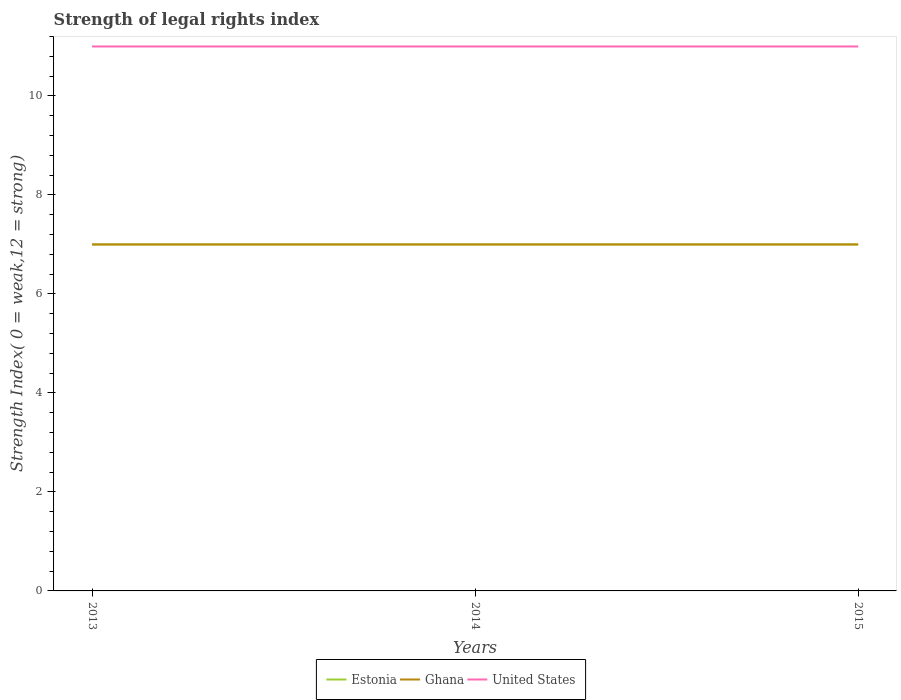How many different coloured lines are there?
Offer a terse response. 3. Does the line corresponding to Estonia intersect with the line corresponding to Ghana?
Provide a short and direct response. Yes. Across all years, what is the maximum strength index in United States?
Offer a very short reply. 11. In which year was the strength index in Estonia maximum?
Keep it short and to the point. 2013. What is the total strength index in Estonia in the graph?
Provide a short and direct response. 0. What is the difference between the highest and the second highest strength index in Estonia?
Your response must be concise. 0. Is the strength index in Ghana strictly greater than the strength index in United States over the years?
Your answer should be very brief. Yes. How many lines are there?
Give a very brief answer. 3. What is the difference between two consecutive major ticks on the Y-axis?
Your answer should be compact. 2. Are the values on the major ticks of Y-axis written in scientific E-notation?
Make the answer very short. No. Does the graph contain grids?
Make the answer very short. No. Where does the legend appear in the graph?
Provide a short and direct response. Bottom center. How are the legend labels stacked?
Provide a succinct answer. Horizontal. What is the title of the graph?
Keep it short and to the point. Strength of legal rights index. Does "Korea (Republic)" appear as one of the legend labels in the graph?
Your answer should be very brief. No. What is the label or title of the Y-axis?
Your answer should be very brief. Strength Index( 0 = weak,12 = strong). What is the Strength Index( 0 = weak,12 = strong) of Estonia in 2014?
Your answer should be compact. 7. What is the Strength Index( 0 = weak,12 = strong) of United States in 2014?
Make the answer very short. 11. What is the Strength Index( 0 = weak,12 = strong) in Estonia in 2015?
Offer a terse response. 7. Across all years, what is the maximum Strength Index( 0 = weak,12 = strong) of Ghana?
Keep it short and to the point. 7. Across all years, what is the maximum Strength Index( 0 = weak,12 = strong) of United States?
Give a very brief answer. 11. What is the total Strength Index( 0 = weak,12 = strong) of Estonia in the graph?
Provide a short and direct response. 21. What is the total Strength Index( 0 = weak,12 = strong) in Ghana in the graph?
Your response must be concise. 21. What is the total Strength Index( 0 = weak,12 = strong) of United States in the graph?
Make the answer very short. 33. What is the difference between the Strength Index( 0 = weak,12 = strong) of Estonia in 2013 and that in 2014?
Offer a very short reply. 0. What is the difference between the Strength Index( 0 = weak,12 = strong) in Ghana in 2013 and that in 2014?
Give a very brief answer. 0. What is the difference between the Strength Index( 0 = weak,12 = strong) in Estonia in 2013 and that in 2015?
Provide a succinct answer. 0. What is the difference between the Strength Index( 0 = weak,12 = strong) in Ghana in 2014 and that in 2015?
Give a very brief answer. 0. What is the difference between the Strength Index( 0 = weak,12 = strong) of United States in 2014 and that in 2015?
Ensure brevity in your answer.  0. What is the difference between the Strength Index( 0 = weak,12 = strong) of Ghana in 2013 and the Strength Index( 0 = weak,12 = strong) of United States in 2014?
Make the answer very short. -4. What is the difference between the Strength Index( 0 = weak,12 = strong) in Estonia in 2013 and the Strength Index( 0 = weak,12 = strong) in United States in 2015?
Make the answer very short. -4. What is the difference between the Strength Index( 0 = weak,12 = strong) in Estonia in 2014 and the Strength Index( 0 = weak,12 = strong) in Ghana in 2015?
Keep it short and to the point. 0. What is the difference between the Strength Index( 0 = weak,12 = strong) in Estonia in 2014 and the Strength Index( 0 = weak,12 = strong) in United States in 2015?
Keep it short and to the point. -4. What is the average Strength Index( 0 = weak,12 = strong) in Estonia per year?
Your response must be concise. 7. What is the average Strength Index( 0 = weak,12 = strong) in Ghana per year?
Ensure brevity in your answer.  7. In the year 2013, what is the difference between the Strength Index( 0 = weak,12 = strong) of Estonia and Strength Index( 0 = weak,12 = strong) of United States?
Your response must be concise. -4. In the year 2014, what is the difference between the Strength Index( 0 = weak,12 = strong) of Estonia and Strength Index( 0 = weak,12 = strong) of Ghana?
Provide a succinct answer. 0. In the year 2015, what is the difference between the Strength Index( 0 = weak,12 = strong) of Estonia and Strength Index( 0 = weak,12 = strong) of Ghana?
Offer a terse response. 0. In the year 2015, what is the difference between the Strength Index( 0 = weak,12 = strong) of Estonia and Strength Index( 0 = weak,12 = strong) of United States?
Provide a succinct answer. -4. In the year 2015, what is the difference between the Strength Index( 0 = weak,12 = strong) of Ghana and Strength Index( 0 = weak,12 = strong) of United States?
Provide a succinct answer. -4. What is the ratio of the Strength Index( 0 = weak,12 = strong) of Estonia in 2013 to that in 2014?
Offer a terse response. 1. What is the ratio of the Strength Index( 0 = weak,12 = strong) in Ghana in 2013 to that in 2015?
Make the answer very short. 1. What is the ratio of the Strength Index( 0 = weak,12 = strong) of Ghana in 2014 to that in 2015?
Ensure brevity in your answer.  1. What is the ratio of the Strength Index( 0 = weak,12 = strong) in United States in 2014 to that in 2015?
Your response must be concise. 1. What is the difference between the highest and the lowest Strength Index( 0 = weak,12 = strong) of United States?
Provide a short and direct response. 0. 